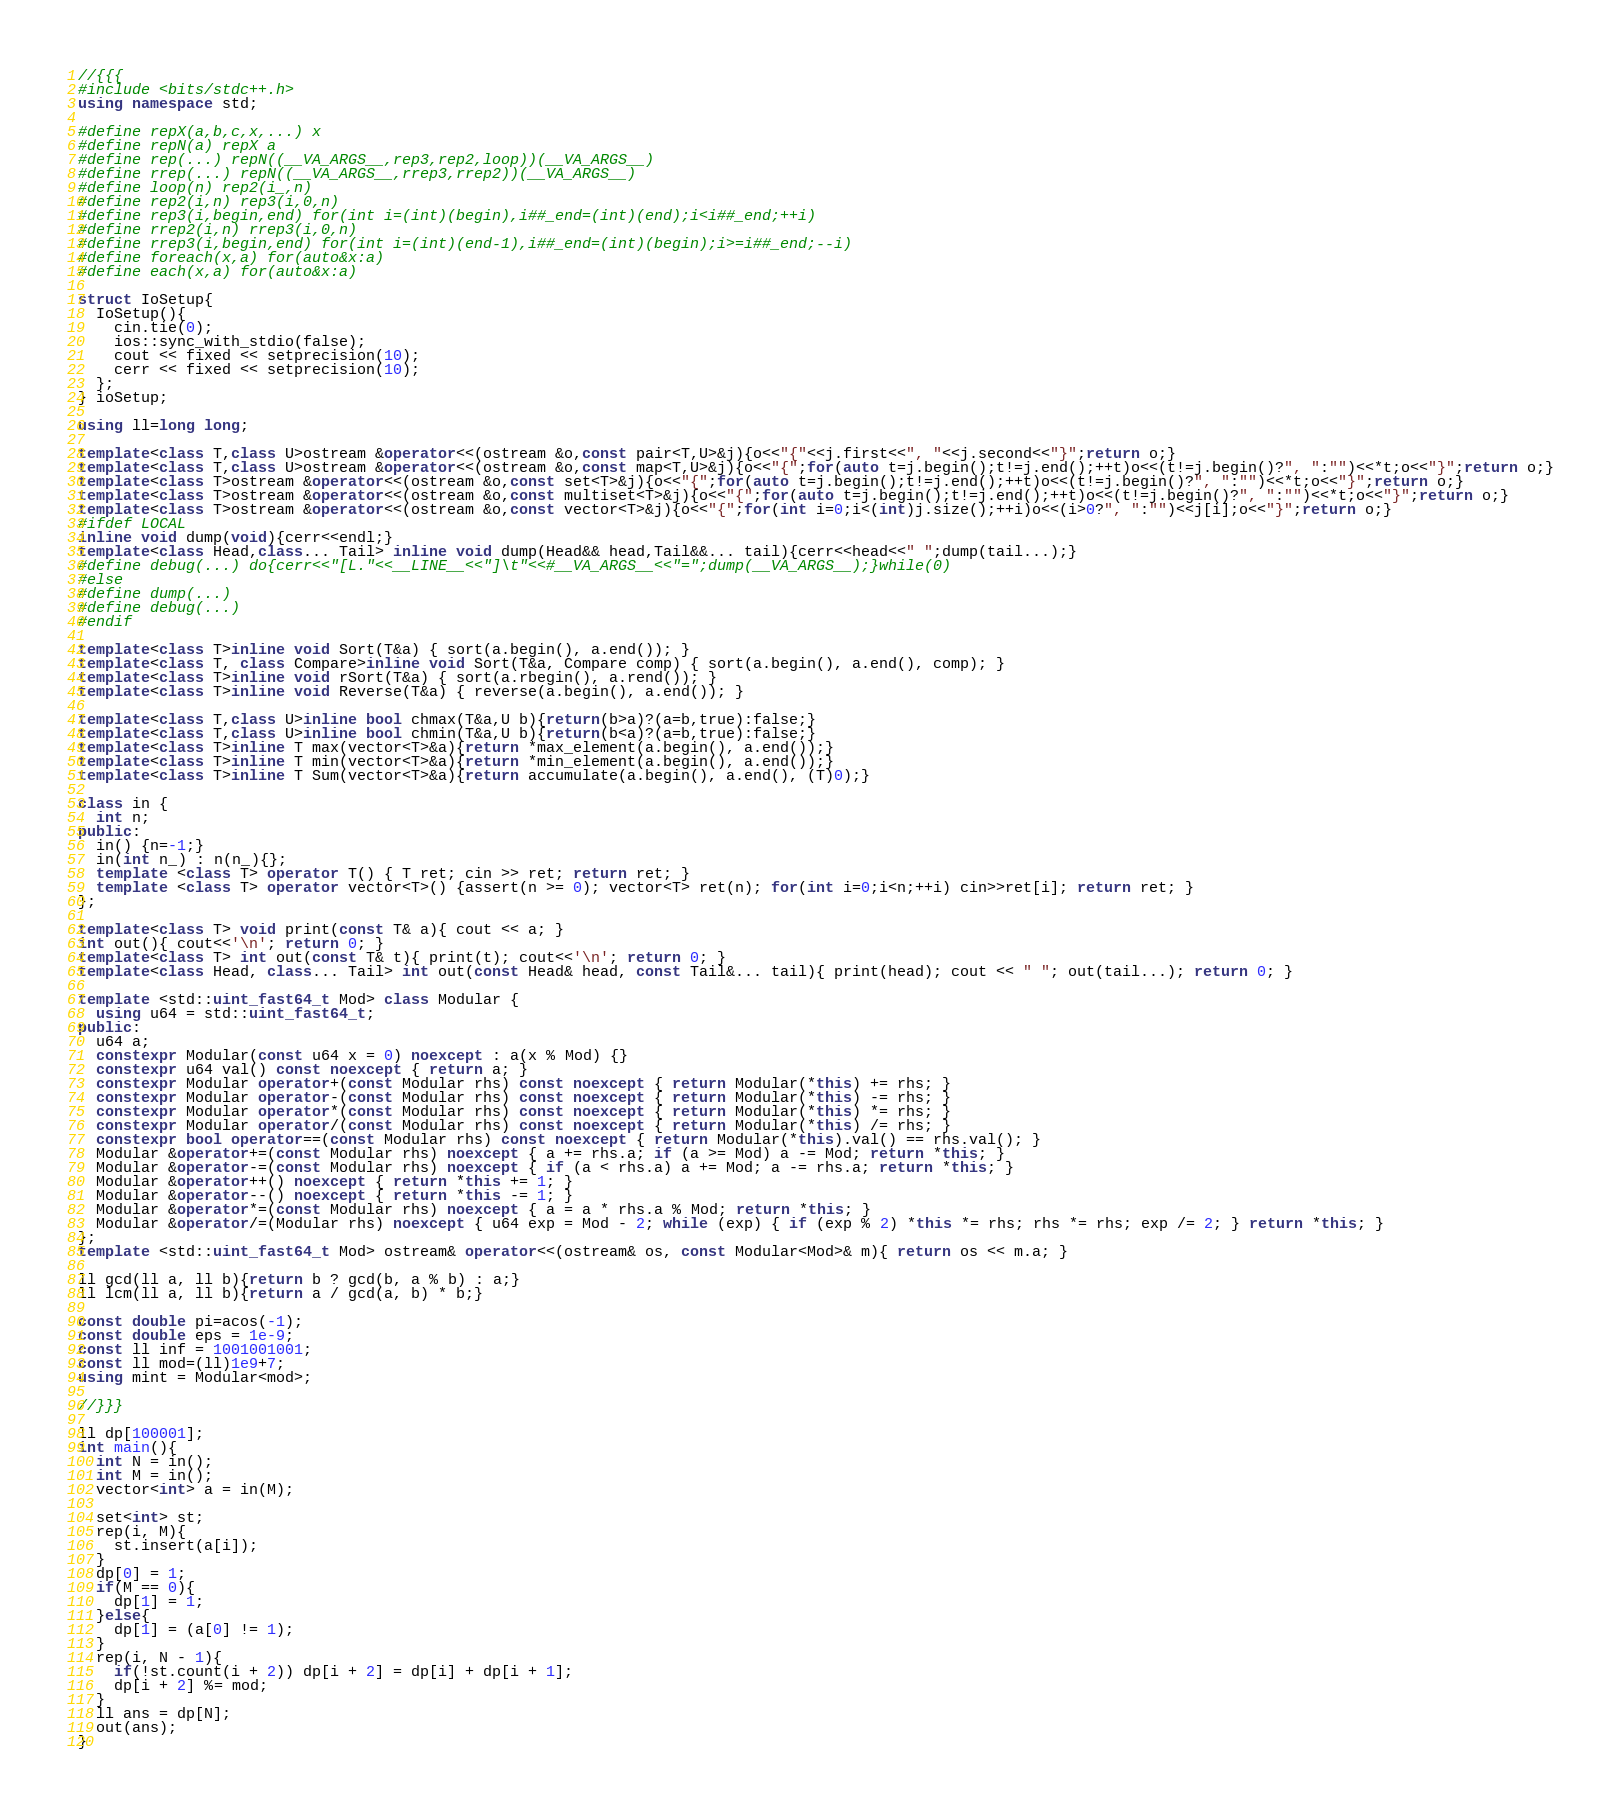<code> <loc_0><loc_0><loc_500><loc_500><_C++_>//{{{
#include <bits/stdc++.h>
using namespace std;

#define repX(a,b,c,x,...) x
#define repN(a) repX a
#define rep(...) repN((__VA_ARGS__,rep3,rep2,loop))(__VA_ARGS__)
#define rrep(...) repN((__VA_ARGS__,rrep3,rrep2))(__VA_ARGS__)
#define loop(n) rep2(i_,n)
#define rep2(i,n) rep3(i,0,n)
#define rep3(i,begin,end) for(int i=(int)(begin),i##_end=(int)(end);i<i##_end;++i)
#define rrep2(i,n) rrep3(i,0,n)
#define rrep3(i,begin,end) for(int i=(int)(end-1),i##_end=(int)(begin);i>=i##_end;--i)
#define foreach(x,a) for(auto&x:a)
#define each(x,a) for(auto&x:a)

struct IoSetup{
  IoSetup(){
    cin.tie(0);
    ios::sync_with_stdio(false);
    cout << fixed << setprecision(10);
    cerr << fixed << setprecision(10);
  };
} ioSetup;

using ll=long long;

template<class T,class U>ostream &operator<<(ostream &o,const pair<T,U>&j){o<<"{"<<j.first<<", "<<j.second<<"}";return o;}
template<class T,class U>ostream &operator<<(ostream &o,const map<T,U>&j){o<<"{";for(auto t=j.begin();t!=j.end();++t)o<<(t!=j.begin()?", ":"")<<*t;o<<"}";return o;}
template<class T>ostream &operator<<(ostream &o,const set<T>&j){o<<"{";for(auto t=j.begin();t!=j.end();++t)o<<(t!=j.begin()?", ":"")<<*t;o<<"}";return o;}
template<class T>ostream &operator<<(ostream &o,const multiset<T>&j){o<<"{";for(auto t=j.begin();t!=j.end();++t)o<<(t!=j.begin()?", ":"")<<*t;o<<"}";return o;}
template<class T>ostream &operator<<(ostream &o,const vector<T>&j){o<<"{";for(int i=0;i<(int)j.size();++i)o<<(i>0?", ":"")<<j[i];o<<"}";return o;}
#ifdef LOCAL
inline void dump(void){cerr<<endl;}
template<class Head,class... Tail> inline void dump(Head&& head,Tail&&... tail){cerr<<head<<" ";dump(tail...);}
#define debug(...) do{cerr<<"[L."<<__LINE__<<"]\t"<<#__VA_ARGS__<<"=";dump(__VA_ARGS__);}while(0)
#else
#define dump(...)
#define debug(...)
#endif

template<class T>inline void Sort(T&a) { sort(a.begin(), a.end()); }
template<class T, class Compare>inline void Sort(T&a, Compare comp) { sort(a.begin(), a.end(), comp); }
template<class T>inline void rSort(T&a) { sort(a.rbegin(), a.rend()); }
template<class T>inline void Reverse(T&a) { reverse(a.begin(), a.end()); }

template<class T,class U>inline bool chmax(T&a,U b){return(b>a)?(a=b,true):false;}
template<class T,class U>inline bool chmin(T&a,U b){return(b<a)?(a=b,true):false;}
template<class T>inline T max(vector<T>&a){return *max_element(a.begin(), a.end());}
template<class T>inline T min(vector<T>&a){return *min_element(a.begin(), a.end());}
template<class T>inline T Sum(vector<T>&a){return accumulate(a.begin(), a.end(), (T)0);}

class in {
  int n;
public:
  in() {n=-1;}
  in(int n_) : n(n_){};
  template <class T> operator T() { T ret; cin >> ret; return ret; }
  template <class T> operator vector<T>() {assert(n >= 0); vector<T> ret(n); for(int i=0;i<n;++i) cin>>ret[i]; return ret; }
};

template<class T> void print(const T& a){ cout << a; }
int out(){ cout<<'\n'; return 0; }
template<class T> int out(const T& t){ print(t); cout<<'\n'; return 0; }
template<class Head, class... Tail> int out(const Head& head, const Tail&... tail){ print(head); cout << " "; out(tail...); return 0; }

template <std::uint_fast64_t Mod> class Modular {
  using u64 = std::uint_fast64_t;
public:
  u64 a;
  constexpr Modular(const u64 x = 0) noexcept : a(x % Mod) {}
  constexpr u64 val() const noexcept { return a; }
  constexpr Modular operator+(const Modular rhs) const noexcept { return Modular(*this) += rhs; }
  constexpr Modular operator-(const Modular rhs) const noexcept { return Modular(*this) -= rhs; }
  constexpr Modular operator*(const Modular rhs) const noexcept { return Modular(*this) *= rhs; }
  constexpr Modular operator/(const Modular rhs) const noexcept { return Modular(*this) /= rhs; }
  constexpr bool operator==(const Modular rhs) const noexcept { return Modular(*this).val() == rhs.val(); }
  Modular &operator+=(const Modular rhs) noexcept { a += rhs.a; if (a >= Mod) a -= Mod; return *this; }
  Modular &operator-=(const Modular rhs) noexcept { if (a < rhs.a) a += Mod; a -= rhs.a; return *this; }
  Modular &operator++() noexcept { return *this += 1; }
  Modular &operator--() noexcept { return *this -= 1; }
  Modular &operator*=(const Modular rhs) noexcept { a = a * rhs.a % Mod; return *this; }
  Modular &operator/=(Modular rhs) noexcept { u64 exp = Mod - 2; while (exp) { if (exp % 2) *this *= rhs; rhs *= rhs; exp /= 2; } return *this; }
};
template <std::uint_fast64_t Mod> ostream& operator<<(ostream& os, const Modular<Mod>& m){ return os << m.a; }

ll gcd(ll a, ll b){return b ? gcd(b, a % b) : a;}
ll lcm(ll a, ll b){return a / gcd(a, b) * b;}

const double pi=acos(-1);
const double eps = 1e-9;
const ll inf = 1001001001;
const ll mod=(ll)1e9+7;
using mint = Modular<mod>;

//}}}

ll dp[100001];
int main(){
  int N = in();
  int M = in();
  vector<int> a = in(M);

  set<int> st;
  rep(i, M){
    st.insert(a[i]);
  }
  dp[0] = 1;
  if(M == 0){
    dp[1] = 1;
  }else{
    dp[1] = (a[0] != 1);
  }
  rep(i, N - 1){
    if(!st.count(i + 2)) dp[i + 2] = dp[i] + dp[i + 1];
    dp[i + 2] %= mod;
  }
  ll ans = dp[N];
  out(ans);
}
</code> 